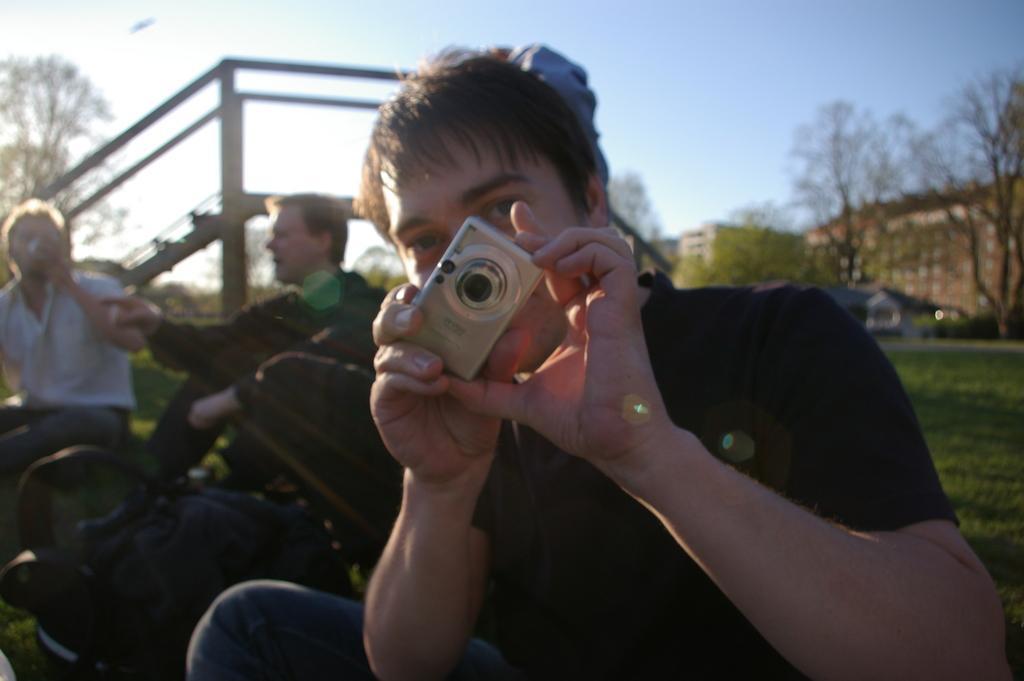Can you describe this image briefly? In this image there are three person siting in the garden. In the front the man is holding a camera. At the back side we can see a building and a tree and a sky. 